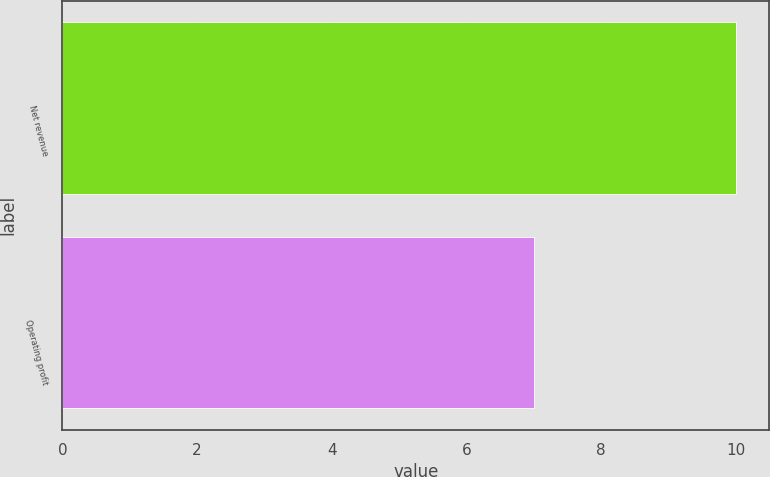<chart> <loc_0><loc_0><loc_500><loc_500><bar_chart><fcel>Net revenue<fcel>Operating profit<nl><fcel>10<fcel>7<nl></chart> 